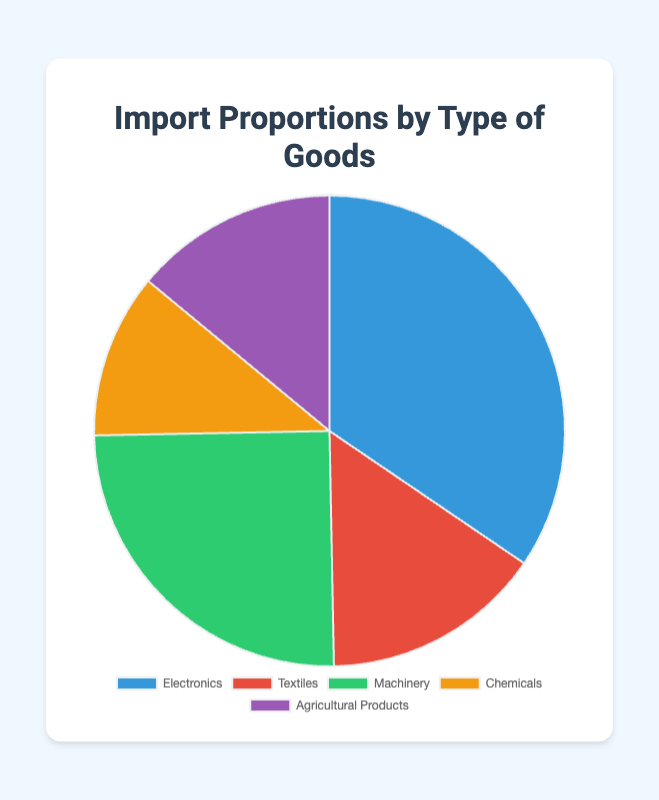What type of goods makes up the largest proportion of imports? The largest proportion of imports is represented by the type of goods with the highest percentage value. Referring to the chart, Electronics has the highest percentage at 34.5%.
Answer: Electronics Which type of good constitutes the smallest portion of imports? The smallest portion of imports is represented by the type of goods with the lowest percentage value. Chemicals have the lowest percentage at 11.3%.
Answer: Chemicals Is the proportion of Machinery imports greater than the combined proportion of Textiles and Agricultural Products? To find out, add the percentages for Textiles and Agricultural Products and then compare to Machinery. Textiles (15.2%) + Agricultural Products (14.0%) = 29.2%, which is less than Machinery's 25.0%. Therefore, no, Machinery's proportion is not greater.
Answer: No What is the difference between the import proportions of Electronics and Chemicals? Subtract the proportion of Chemicals from Electronics. Electronics (34.5%) - Chemicals (11.3%) = 23.2%.
Answer: 23.2% What percentage of imports do Textiles and Chemicals together make up? Sum the percentages of Textiles and Chemicals. Textiles (15.2%) + Chemicals (11.3%) = 26.5%.
Answer: 26.5% Which type of goods has a proportion closest to 15%? Compare each type of goods' percentage to 15% and find the closest one. Textiles has a percentage of 15.2%, which is closest to 15%.
Answer: Textiles If the total value of imports were $1,000,000, what would be the value of Electronics imports? Multiply the total value by the percentage for Electronics. $1,000,000 * 34.5% = $345,000.
Answer: $345,000 How do the proportions of Machinery and Agricultural Products compare? Directly compare the two percentages. Machinery (25.0%) is greater than Agricultural Products (14.0%).
Answer: Machinery is greater Which color represents Agricultural Products in the pie chart? Looking at the color scheme in the legend, Agricultural Products is represented by the fifth color, which is purple.
Answer: Purple What is the average proportion of imports for all the types of goods combined? Sum all the percentages and divide by the number of types of goods. (34.5% + 15.2% + 25.0% + 11.3% + 14.0%) / 5 = 100% / 5 = 20%.
Answer: 20% 